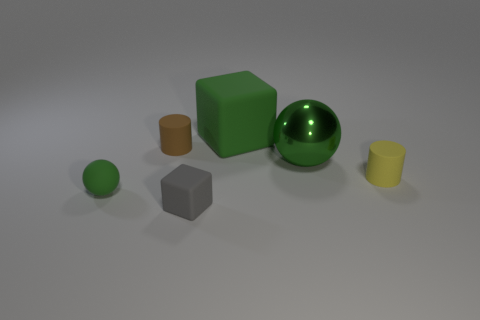Add 2 yellow matte things. How many objects exist? 8 Subtract all cylinders. How many objects are left? 4 Add 2 gray things. How many gray things exist? 3 Subtract 0 red cylinders. How many objects are left? 6 Subtract all rubber objects. Subtract all big green rubber objects. How many objects are left? 0 Add 1 cylinders. How many cylinders are left? 3 